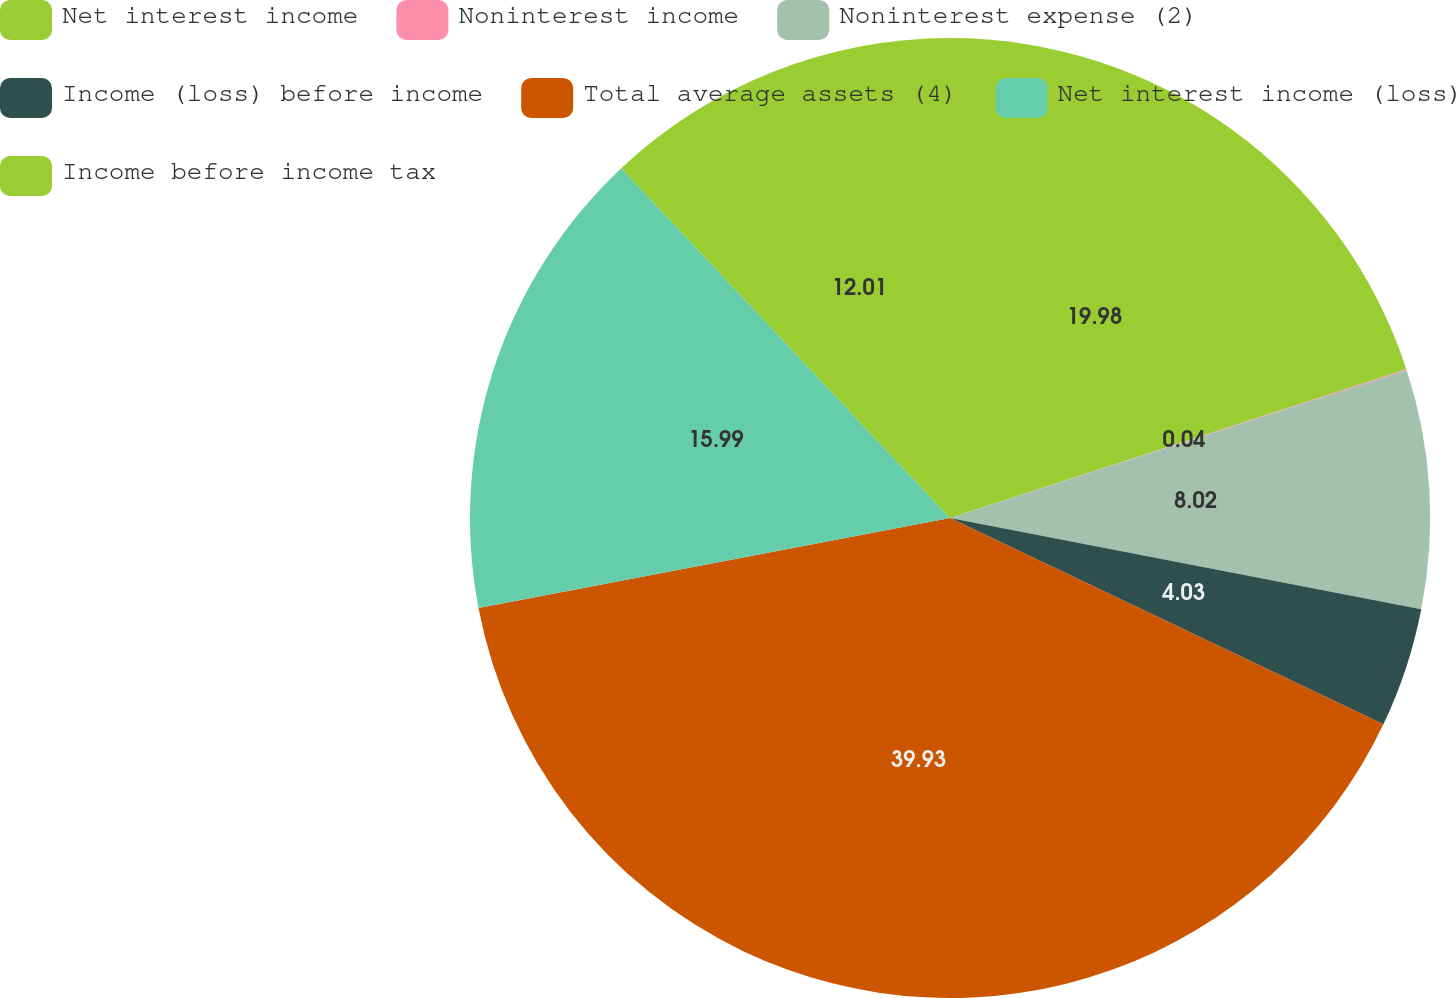Convert chart. <chart><loc_0><loc_0><loc_500><loc_500><pie_chart><fcel>Net interest income<fcel>Noninterest income<fcel>Noninterest expense (2)<fcel>Income (loss) before income<fcel>Total average assets (4)<fcel>Net interest income (loss)<fcel>Income before income tax<nl><fcel>19.99%<fcel>0.04%<fcel>8.02%<fcel>4.03%<fcel>39.94%<fcel>16.0%<fcel>12.01%<nl></chart> 